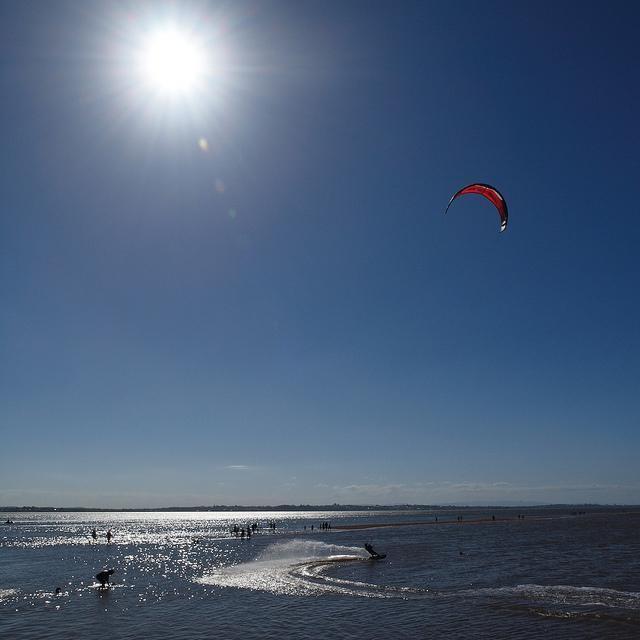How many horses in the photo?
Give a very brief answer. 0. 